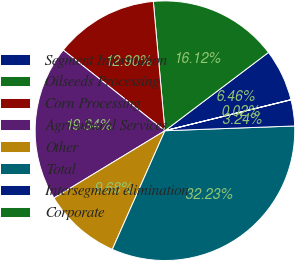<chart> <loc_0><loc_0><loc_500><loc_500><pie_chart><fcel>Segment Information<fcel>Oilseeds Processing<fcel>Corn Processing<fcel>Agricultural Services<fcel>Other<fcel>Total<fcel>Intersegment elimination<fcel>Corporate<nl><fcel>6.46%<fcel>16.12%<fcel>12.9%<fcel>19.34%<fcel>9.68%<fcel>32.22%<fcel>3.24%<fcel>0.02%<nl></chart> 